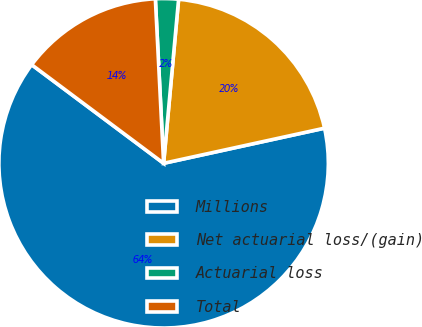Convert chart. <chart><loc_0><loc_0><loc_500><loc_500><pie_chart><fcel>Millions<fcel>Net actuarial loss/(gain)<fcel>Actuarial loss<fcel>Total<nl><fcel>63.64%<fcel>20.13%<fcel>2.25%<fcel>13.99%<nl></chart> 